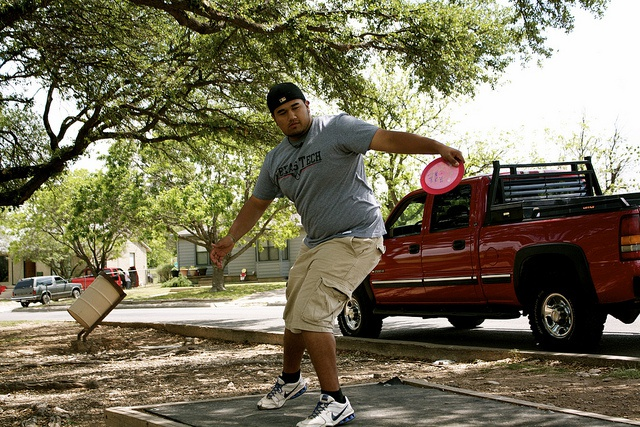Describe the objects in this image and their specific colors. I can see truck in gray, black, maroon, and white tones, people in gray, black, and maroon tones, car in gray, black, darkgray, and lightgray tones, frisbee in gray, lightpink, brown, and salmon tones, and truck in gray, black, brown, and maroon tones in this image. 